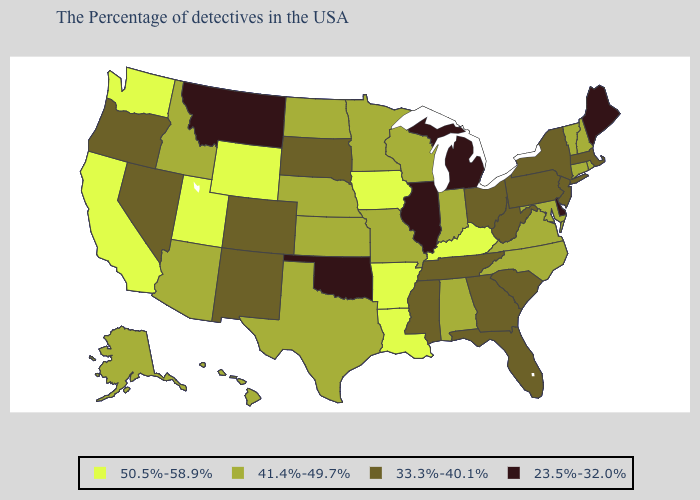Among the states that border California , which have the highest value?
Short answer required. Arizona. Does the first symbol in the legend represent the smallest category?
Give a very brief answer. No. What is the lowest value in the MidWest?
Short answer required. 23.5%-32.0%. How many symbols are there in the legend?
Short answer required. 4. Name the states that have a value in the range 23.5%-32.0%?
Be succinct. Maine, Delaware, Michigan, Illinois, Oklahoma, Montana. Among the states that border New Mexico , does Oklahoma have the lowest value?
Short answer required. Yes. Is the legend a continuous bar?
Answer briefly. No. Name the states that have a value in the range 33.3%-40.1%?
Give a very brief answer. Massachusetts, New York, New Jersey, Pennsylvania, South Carolina, West Virginia, Ohio, Florida, Georgia, Tennessee, Mississippi, South Dakota, Colorado, New Mexico, Nevada, Oregon. What is the value of Louisiana?
Quick response, please. 50.5%-58.9%. Does Connecticut have a lower value than South Dakota?
Answer briefly. No. Name the states that have a value in the range 50.5%-58.9%?
Keep it brief. Kentucky, Louisiana, Arkansas, Iowa, Wyoming, Utah, California, Washington. Does Tennessee have the same value as Mississippi?
Concise answer only. Yes. What is the value of Wisconsin?
Keep it brief. 41.4%-49.7%. Name the states that have a value in the range 23.5%-32.0%?
Answer briefly. Maine, Delaware, Michigan, Illinois, Oklahoma, Montana. Among the states that border Iowa , does Nebraska have the lowest value?
Answer briefly. No. 